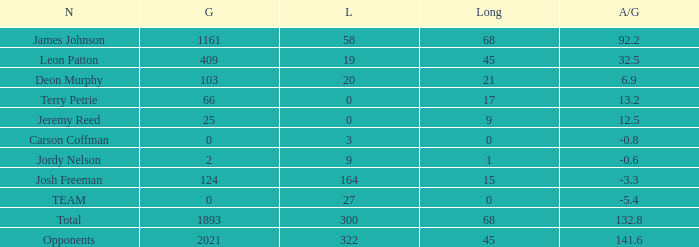How many losses did leon patton have with the longest gain higher than 45? 0.0. 